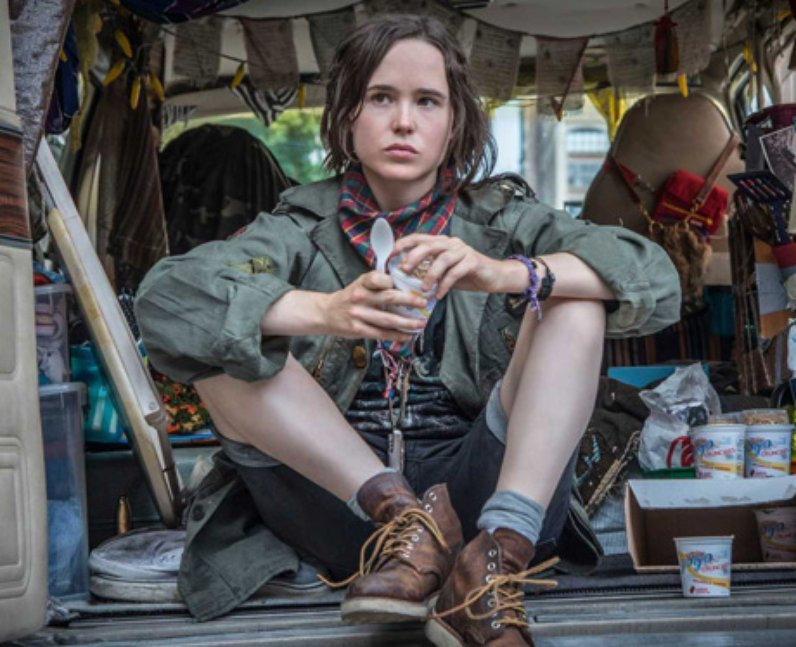Can you elaborate on the elements of the picture provided? The image features an individual, Elliot Page, seated in a van that appears to be a mobile home or workspace, cluttered with numerous objects. Dressed in a practical and somewhat rugged outfit, consisting of a green jacket, a red scarf, and brown boots, Page exudes a contemplative vibe. Page is holding a rainbow-colored ribbon, a detail that may symbolize diversity or personal identity. The environment is accessorized with items like paper notes, possibly scripts, and various personal belongings that suggest a setting that combines personal space with a professional backdrop. This setting, combined with Page’s serious expression, portrays a scene of deep personal engagement or reflection, potentially about their life or the character they are portraying. 